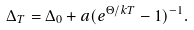Convert formula to latex. <formula><loc_0><loc_0><loc_500><loc_500>\Delta _ { T } = \Delta _ { 0 } + a ( e ^ { \Theta / k T } - 1 ) ^ { - 1 } .</formula> 